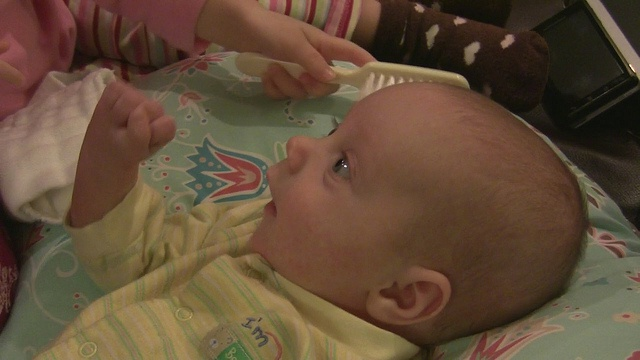Describe the objects in this image and their specific colors. I can see people in brown, maroon, and gray tones and people in brown and maroon tones in this image. 